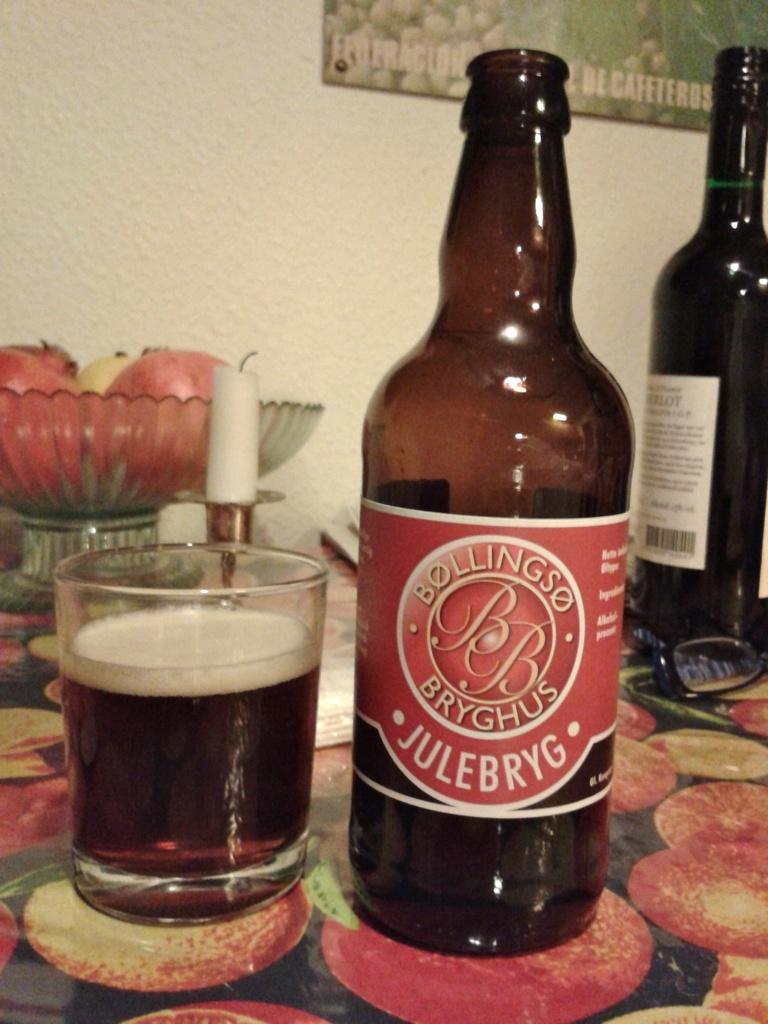Could you give a brief overview of what you see in this image? There is a table with colorful mat. On the table there is a tray with fruits, candle with stand, glass, two bottles with label and a specs. In the background there is a wall with photo frame. 